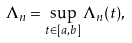<formula> <loc_0><loc_0><loc_500><loc_500>\Lambda _ { n } = \sup _ { t \in [ a , b ] } \Lambda _ { n } ( t ) ,</formula> 